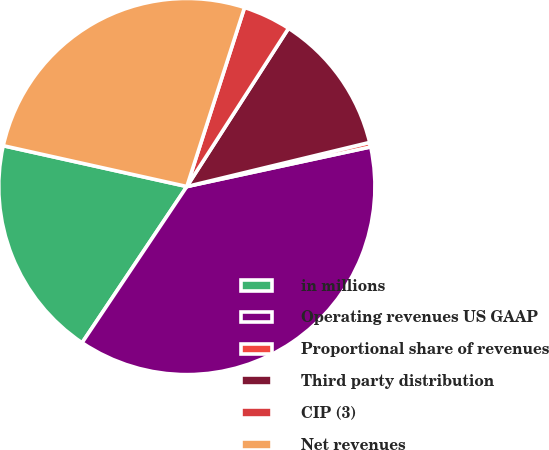Convert chart. <chart><loc_0><loc_0><loc_500><loc_500><pie_chart><fcel>in millions<fcel>Operating revenues US GAAP<fcel>Proportional share of revenues<fcel>Third party distribution<fcel>CIP (3)<fcel>Net revenues<nl><fcel>19.08%<fcel>37.78%<fcel>0.39%<fcel>12.14%<fcel>4.13%<fcel>26.48%<nl></chart> 